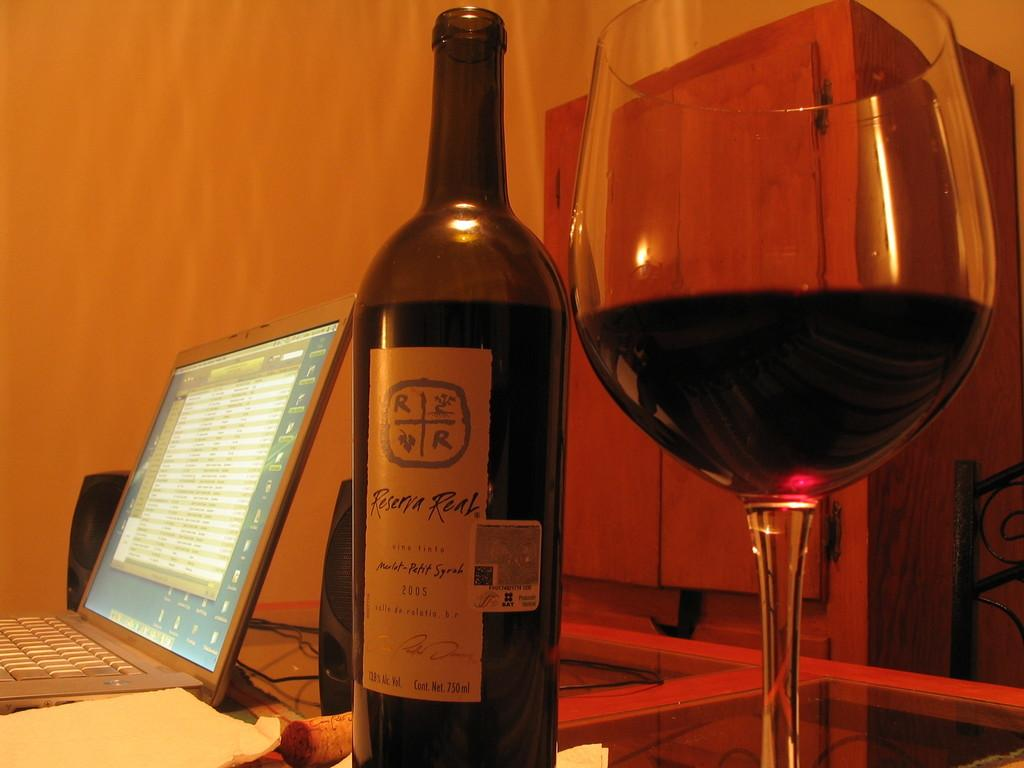<image>
Present a compact description of the photo's key features. A bottle of wine is dated with the year 2005. 